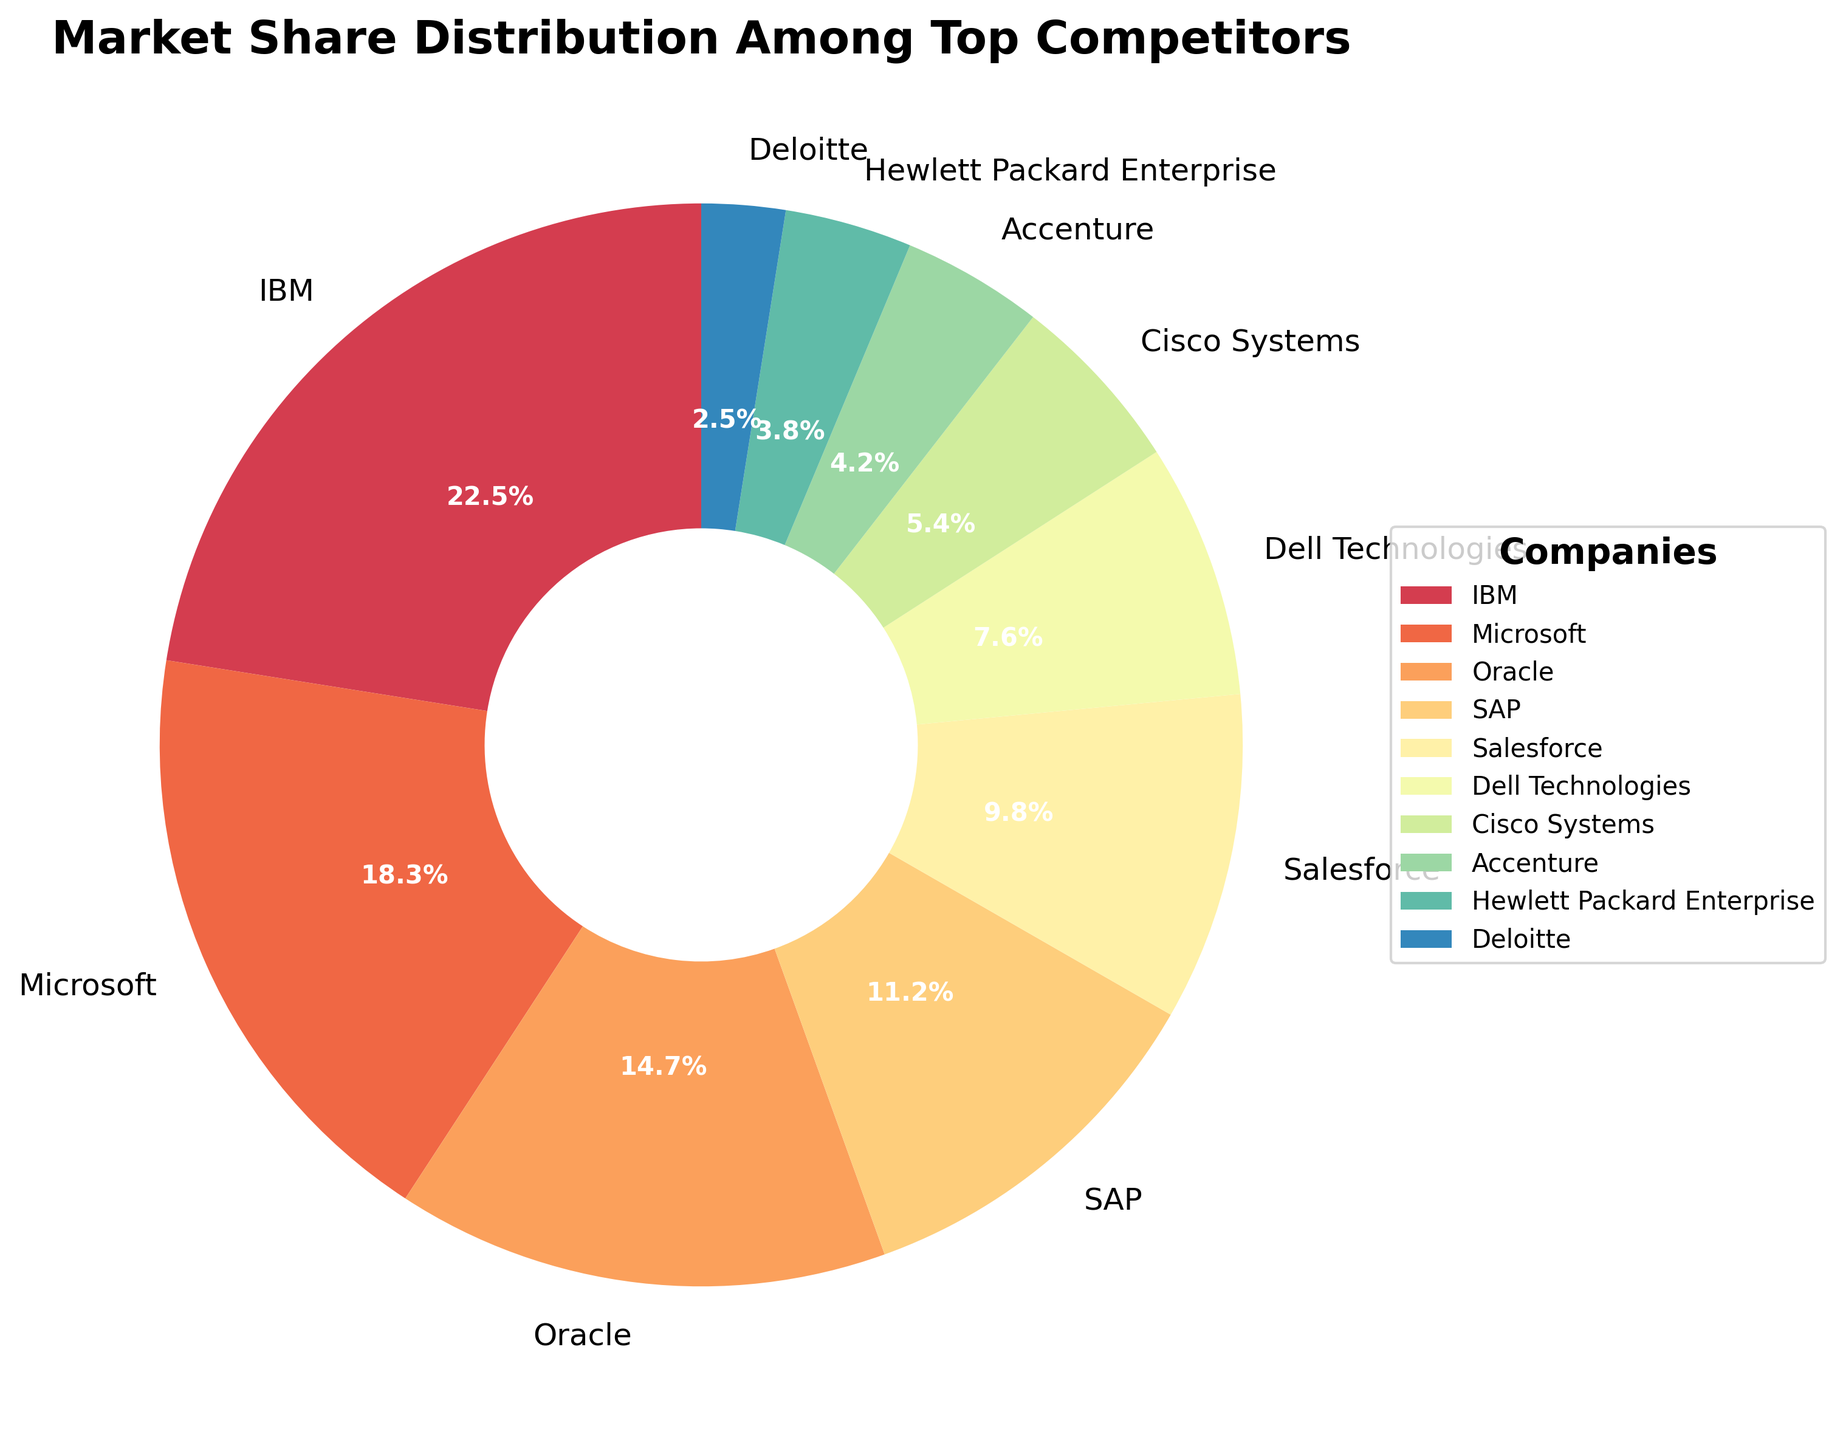What's the combined market share of Microsoft and Oracle? To find the combined market share of Microsoft and Oracle, we sum their individual market shares. From the figure, Microsoft has a market share of 18.3% and Oracle has 14.7%. Therefore, 18.3% + 14.7% = 33%.
Answer: 33% Which company has the smallest market share, and what is it? By observing the pie chart, Deloitte has the smallest market share. The market share for Deloitte, as displayed on the chart, is 2.5%.
Answer: Deloitte with 2.5% How much larger is IBM's market share compared to Salesforce's? To determine how much larger IBM's market share is compared to Salesforce's, we subtract Salesforce's market share from IBM's. IBM's market share is 22.5% and Salesforce's is 9.8%, so 22.5% - 9.8% = 12.7%.
Answer: 12.7% What is the sum of market shares for SAP, Dell Technologies, and Cisco Systems? To find the total market share of SAP, Dell Technologies, and Cisco Systems, we add their individual market shares. SAP has 11.2%, Dell Technologies has 7.6%, and Cisco Systems has 5.4%. Therefore, 11.2% + 7.6% + 5.4% = 24.2%.
Answer: 24.2% Which companies have a market share greater than 10%? According to the pie chart, companies with a market share greater than 10% are IBM, Microsoft, Oracle, and SAP. Their market shares are all above this threshold.
Answer: IBM, Microsoft, Oracle, SAP What is the average market share of the top three companies? To find the average market share of the top three companies (IBM, Microsoft, and Oracle), we add their market shares and divide by three. IBM has 22.5%, Microsoft has 18.3%, and Oracle has 14.7%. Thus, (22.5% + 18.3% + 14.7%) / 3 = 18.5%.
Answer: 18.5% How does Accenture’s market share compare to Hewlett Packard Enterprise's? Looking at the pie chart, Accenture has a market share of 4.2%, while Hewlett Packard Enterprise has 3.8%. Comparing their shares, Accenture's market share is slightly higher than Hewlett Packard Enterprise's.
Answer: Accenture has a higher market share Among the companies listed, which one has the third-largest market share? By inspecting the pie chart, Oracle has the third-largest market share, following IBM and Microsoft. Oracle's market share is 14.7%.
Answer: Oracle What market share percentage is covered by the companies with less than 5% market share each? We sum up the market shares of Cisco Systems (5.4%), Accenture (4.2%), Hewlett Packard Enterprise (3.8%), and Deloitte (2.5%). Thus, 5.4% + 4.2% + 3.8% + 2.5% = 15.9% but only Accenture is below 5%. Therefore, 4.2% + 3.8% + 2.5% = 10.5%.
Answer: 10.5% How many companies have a market share less than the average market share of Hewlett Packard Enterprise and Deloitte? To find how many companies have a market share less than the average of Hewlett Packard Enterprise and Deloitte, we first find their average. Hewlett Packard Enterprise has 3.8%, and Deloitte has 2.5%. Thus, (3.8% + 2.5%) / 2 = 3.15%. Only Deloitte has less than 3.15%.
Answer: 1 